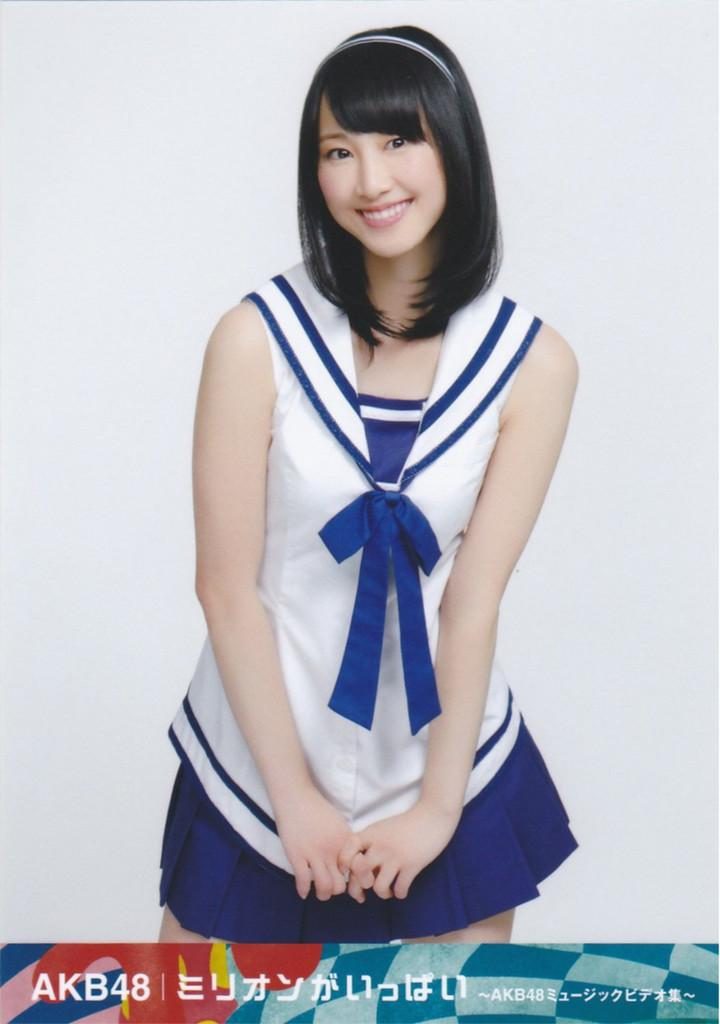Provide a one-sentence caption for the provided image. a young female picture with AKB48 and Japanese language at the bottom. 